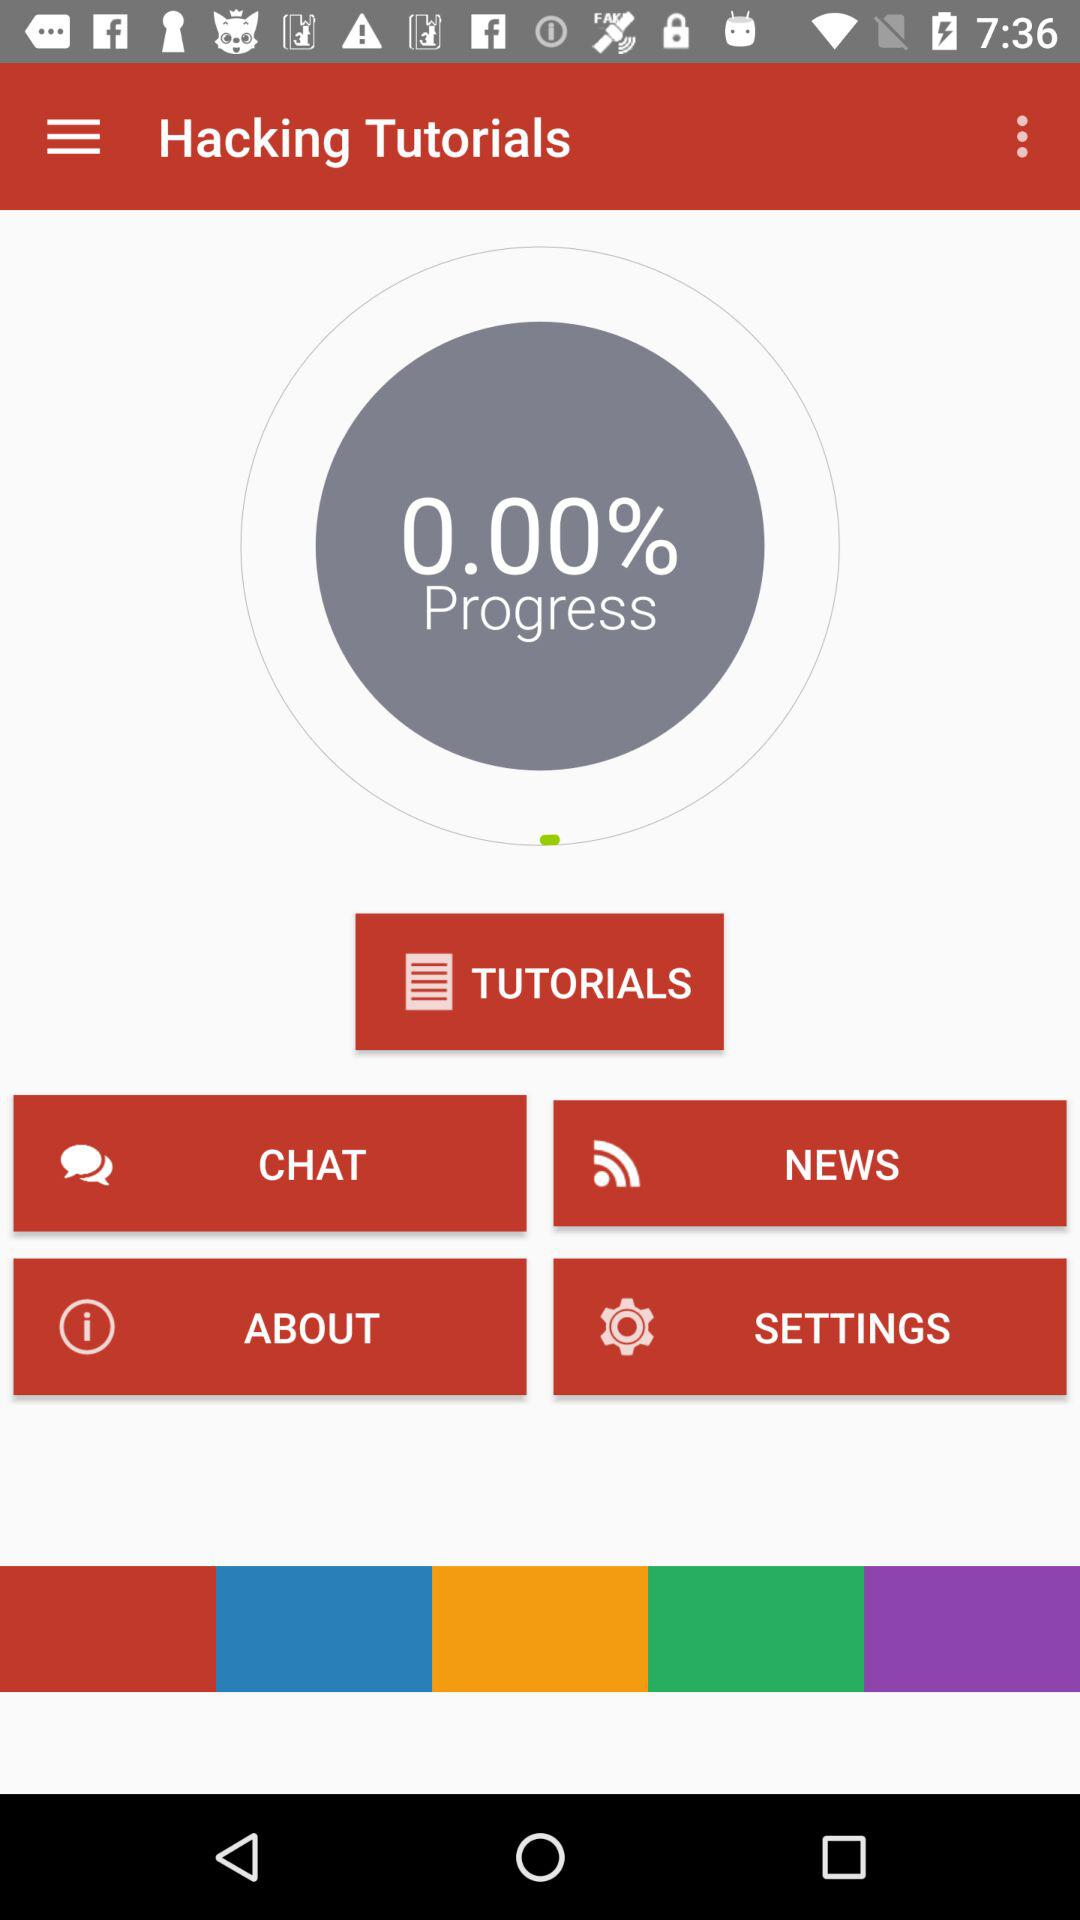How much progress is shown on the progress bar?
Answer the question using a single word or phrase. 0.00% 